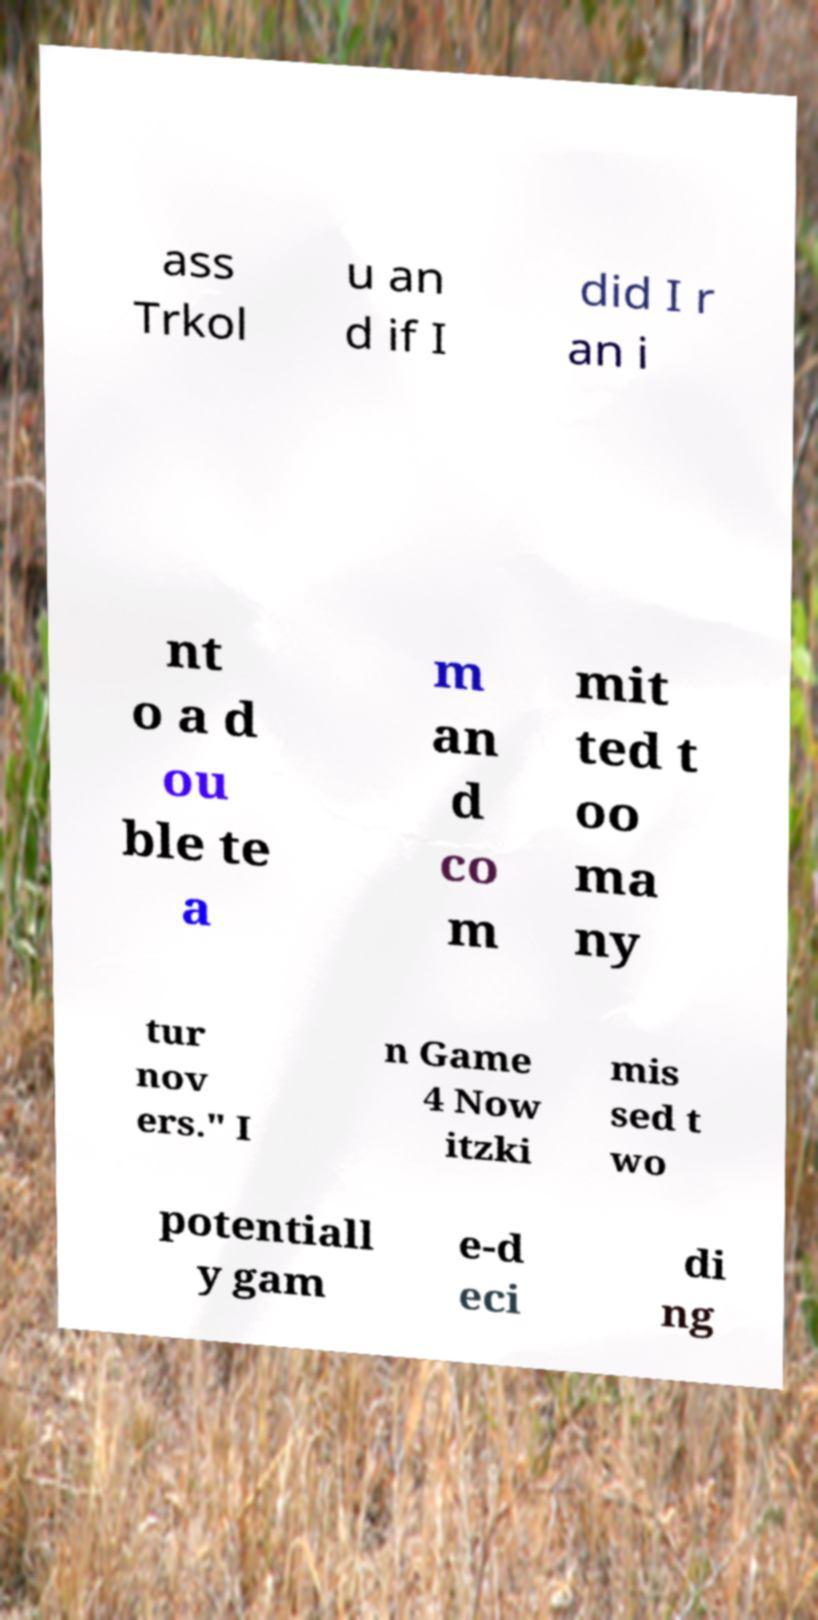Please read and relay the text visible in this image. What does it say? ass Trkol u an d if I did I r an i nt o a d ou ble te a m an d co m mit ted t oo ma ny tur nov ers." I n Game 4 Now itzki mis sed t wo potentiall y gam e-d eci di ng 